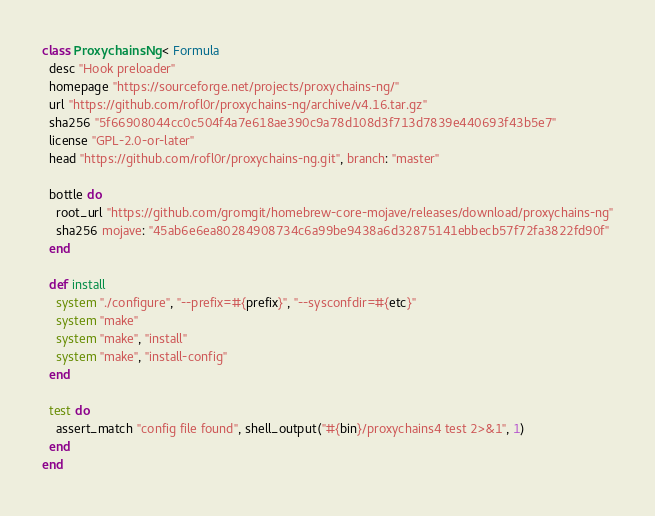<code> <loc_0><loc_0><loc_500><loc_500><_Ruby_>class ProxychainsNg < Formula
  desc "Hook preloader"
  homepage "https://sourceforge.net/projects/proxychains-ng/"
  url "https://github.com/rofl0r/proxychains-ng/archive/v4.16.tar.gz"
  sha256 "5f66908044cc0c504f4a7e618ae390c9a78d108d3f713d7839e440693f43b5e7"
  license "GPL-2.0-or-later"
  head "https://github.com/rofl0r/proxychains-ng.git", branch: "master"

  bottle do
    root_url "https://github.com/gromgit/homebrew-core-mojave/releases/download/proxychains-ng"
    sha256 mojave: "45ab6e6ea80284908734c6a99be9438a6d32875141ebbecb57f72fa3822fd90f"
  end

  def install
    system "./configure", "--prefix=#{prefix}", "--sysconfdir=#{etc}"
    system "make"
    system "make", "install"
    system "make", "install-config"
  end

  test do
    assert_match "config file found", shell_output("#{bin}/proxychains4 test 2>&1", 1)
  end
end
</code> 